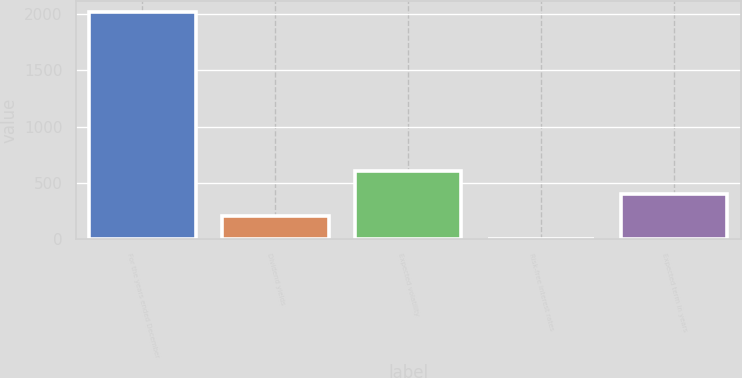Convert chart. <chart><loc_0><loc_0><loc_500><loc_500><bar_chart><fcel>For the years ended December<fcel>Dividend yields<fcel>Expected volatility<fcel>Risk-free interest rates<fcel>Expected term in years<nl><fcel>2016<fcel>202.95<fcel>605.85<fcel>1.5<fcel>404.4<nl></chart> 